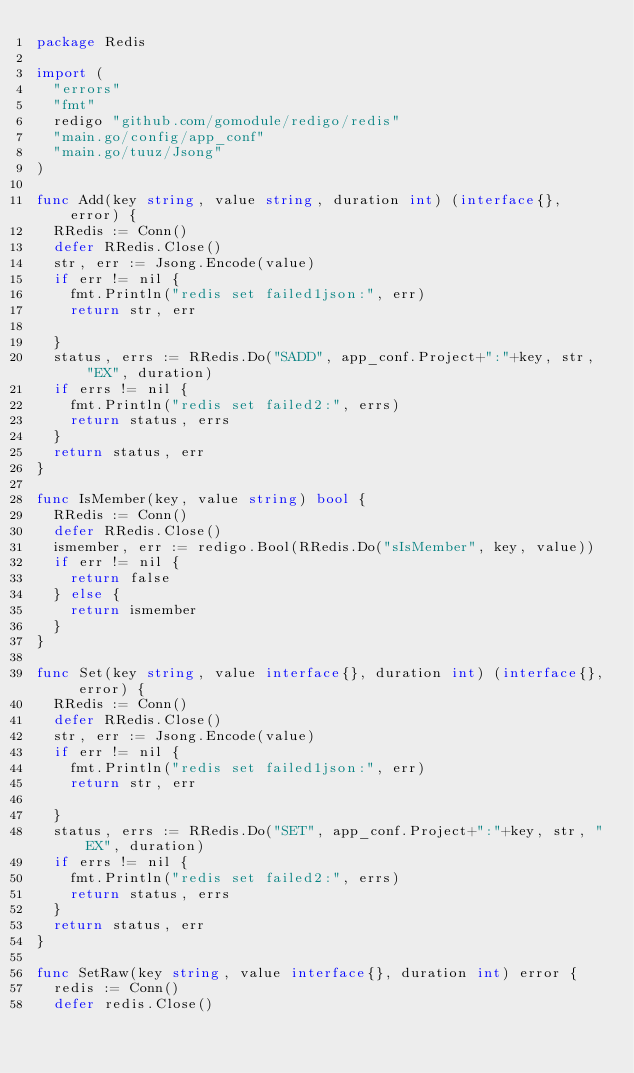Convert code to text. <code><loc_0><loc_0><loc_500><loc_500><_Go_>package Redis

import (
	"errors"
	"fmt"
	redigo "github.com/gomodule/redigo/redis"
	"main.go/config/app_conf"
	"main.go/tuuz/Jsong"
)

func Add(key string, value string, duration int) (interface{}, error) {
	RRedis := Conn()
	defer RRedis.Close()
	str, err := Jsong.Encode(value)
	if err != nil {
		fmt.Println("redis set failed1json:", err)
		return str, err

	}
	status, errs := RRedis.Do("SADD", app_conf.Project+":"+key, str, "EX", duration)
	if errs != nil {
		fmt.Println("redis set failed2:", errs)
		return status, errs
	}
	return status, err
}

func IsMember(key, value string) bool {
	RRedis := Conn()
	defer RRedis.Close()
	ismember, err := redigo.Bool(RRedis.Do("sIsMember", key, value))
	if err != nil {
		return false
	} else {
		return ismember
	}
}

func Set(key string, value interface{}, duration int) (interface{}, error) {
	RRedis := Conn()
	defer RRedis.Close()
	str, err := Jsong.Encode(value)
	if err != nil {
		fmt.Println("redis set failed1json:", err)
		return str, err

	}
	status, errs := RRedis.Do("SET", app_conf.Project+":"+key, str, "EX", duration)
	if errs != nil {
		fmt.Println("redis set failed2:", errs)
		return status, errs
	}
	return status, err
}

func SetRaw(key string, value interface{}, duration int) error {
	redis := Conn()
	defer redis.Close()</code> 